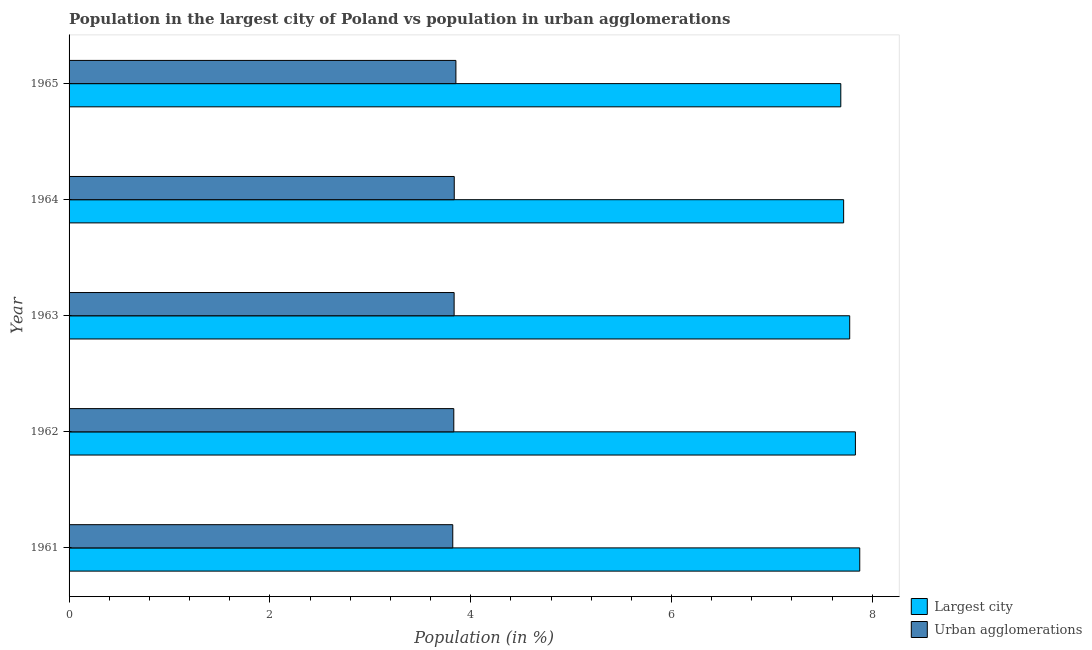How many groups of bars are there?
Provide a succinct answer. 5. How many bars are there on the 2nd tick from the top?
Provide a succinct answer. 2. How many bars are there on the 3rd tick from the bottom?
Your response must be concise. 2. What is the label of the 5th group of bars from the top?
Ensure brevity in your answer.  1961. In how many cases, is the number of bars for a given year not equal to the number of legend labels?
Your response must be concise. 0. What is the population in urban agglomerations in 1961?
Give a very brief answer. 3.82. Across all years, what is the maximum population in the largest city?
Offer a terse response. 7.88. Across all years, what is the minimum population in urban agglomerations?
Offer a terse response. 3.82. In which year was the population in the largest city minimum?
Provide a short and direct response. 1965. What is the total population in the largest city in the graph?
Your response must be concise. 38.88. What is the difference between the population in urban agglomerations in 1963 and that in 1964?
Ensure brevity in your answer.  -0. What is the difference between the population in the largest city in 1963 and the population in urban agglomerations in 1965?
Offer a very short reply. 3.92. What is the average population in urban agglomerations per year?
Offer a very short reply. 3.84. In the year 1961, what is the difference between the population in urban agglomerations and population in the largest city?
Ensure brevity in your answer.  -4.05. What is the difference between the highest and the second highest population in urban agglomerations?
Your answer should be very brief. 0.02. What is the difference between the highest and the lowest population in urban agglomerations?
Keep it short and to the point. 0.03. In how many years, is the population in the largest city greater than the average population in the largest city taken over all years?
Provide a short and direct response. 2. What does the 2nd bar from the top in 1964 represents?
Give a very brief answer. Largest city. What does the 1st bar from the bottom in 1961 represents?
Provide a succinct answer. Largest city. Are all the bars in the graph horizontal?
Give a very brief answer. Yes. What is the difference between two consecutive major ticks on the X-axis?
Offer a very short reply. 2. Are the values on the major ticks of X-axis written in scientific E-notation?
Make the answer very short. No. Does the graph contain any zero values?
Your answer should be compact. No. Does the graph contain grids?
Offer a terse response. No. Where does the legend appear in the graph?
Your answer should be very brief. Bottom right. How many legend labels are there?
Your response must be concise. 2. How are the legend labels stacked?
Offer a terse response. Vertical. What is the title of the graph?
Keep it short and to the point. Population in the largest city of Poland vs population in urban agglomerations. What is the label or title of the X-axis?
Your answer should be very brief. Population (in %). What is the Population (in %) of Largest city in 1961?
Offer a terse response. 7.88. What is the Population (in %) of Urban agglomerations in 1961?
Offer a terse response. 3.82. What is the Population (in %) in Largest city in 1962?
Offer a very short reply. 7.83. What is the Population (in %) in Urban agglomerations in 1962?
Your response must be concise. 3.83. What is the Population (in %) of Largest city in 1963?
Give a very brief answer. 7.78. What is the Population (in %) of Urban agglomerations in 1963?
Keep it short and to the point. 3.84. What is the Population (in %) of Largest city in 1964?
Ensure brevity in your answer.  7.71. What is the Population (in %) in Urban agglomerations in 1964?
Ensure brevity in your answer.  3.84. What is the Population (in %) in Largest city in 1965?
Your answer should be compact. 7.69. What is the Population (in %) of Urban agglomerations in 1965?
Offer a very short reply. 3.85. Across all years, what is the maximum Population (in %) in Largest city?
Offer a terse response. 7.88. Across all years, what is the maximum Population (in %) in Urban agglomerations?
Provide a short and direct response. 3.85. Across all years, what is the minimum Population (in %) in Largest city?
Your response must be concise. 7.69. Across all years, what is the minimum Population (in %) in Urban agglomerations?
Provide a short and direct response. 3.82. What is the total Population (in %) of Largest city in the graph?
Your answer should be very brief. 38.88. What is the total Population (in %) in Urban agglomerations in the graph?
Offer a terse response. 19.18. What is the difference between the Population (in %) in Largest city in 1961 and that in 1962?
Your answer should be very brief. 0.04. What is the difference between the Population (in %) of Urban agglomerations in 1961 and that in 1962?
Make the answer very short. -0.01. What is the difference between the Population (in %) of Largest city in 1961 and that in 1963?
Give a very brief answer. 0.1. What is the difference between the Population (in %) in Urban agglomerations in 1961 and that in 1963?
Your answer should be compact. -0.01. What is the difference between the Population (in %) in Largest city in 1961 and that in 1964?
Offer a terse response. 0.16. What is the difference between the Population (in %) of Urban agglomerations in 1961 and that in 1964?
Offer a very short reply. -0.01. What is the difference between the Population (in %) of Largest city in 1961 and that in 1965?
Offer a very short reply. 0.19. What is the difference between the Population (in %) of Urban agglomerations in 1961 and that in 1965?
Your answer should be very brief. -0.03. What is the difference between the Population (in %) of Largest city in 1962 and that in 1963?
Give a very brief answer. 0.06. What is the difference between the Population (in %) in Urban agglomerations in 1962 and that in 1963?
Your answer should be very brief. -0. What is the difference between the Population (in %) of Largest city in 1962 and that in 1964?
Offer a terse response. 0.12. What is the difference between the Population (in %) of Urban agglomerations in 1962 and that in 1964?
Provide a succinct answer. -0. What is the difference between the Population (in %) of Largest city in 1962 and that in 1965?
Provide a short and direct response. 0.15. What is the difference between the Population (in %) of Urban agglomerations in 1962 and that in 1965?
Make the answer very short. -0.02. What is the difference between the Population (in %) of Largest city in 1963 and that in 1964?
Offer a very short reply. 0.06. What is the difference between the Population (in %) in Urban agglomerations in 1963 and that in 1964?
Offer a very short reply. -0. What is the difference between the Population (in %) in Largest city in 1963 and that in 1965?
Keep it short and to the point. 0.09. What is the difference between the Population (in %) of Urban agglomerations in 1963 and that in 1965?
Your answer should be compact. -0.02. What is the difference between the Population (in %) in Largest city in 1964 and that in 1965?
Give a very brief answer. 0.03. What is the difference between the Population (in %) of Urban agglomerations in 1964 and that in 1965?
Your answer should be compact. -0.02. What is the difference between the Population (in %) in Largest city in 1961 and the Population (in %) in Urban agglomerations in 1962?
Ensure brevity in your answer.  4.04. What is the difference between the Population (in %) in Largest city in 1961 and the Population (in %) in Urban agglomerations in 1963?
Give a very brief answer. 4.04. What is the difference between the Population (in %) of Largest city in 1961 and the Population (in %) of Urban agglomerations in 1964?
Provide a succinct answer. 4.04. What is the difference between the Population (in %) in Largest city in 1961 and the Population (in %) in Urban agglomerations in 1965?
Offer a terse response. 4.02. What is the difference between the Population (in %) in Largest city in 1962 and the Population (in %) in Urban agglomerations in 1963?
Make the answer very short. 4. What is the difference between the Population (in %) in Largest city in 1962 and the Population (in %) in Urban agglomerations in 1964?
Your answer should be compact. 4. What is the difference between the Population (in %) of Largest city in 1962 and the Population (in %) of Urban agglomerations in 1965?
Your answer should be compact. 3.98. What is the difference between the Population (in %) in Largest city in 1963 and the Population (in %) in Urban agglomerations in 1964?
Provide a short and direct response. 3.94. What is the difference between the Population (in %) in Largest city in 1963 and the Population (in %) in Urban agglomerations in 1965?
Offer a terse response. 3.92. What is the difference between the Population (in %) of Largest city in 1964 and the Population (in %) of Urban agglomerations in 1965?
Your answer should be very brief. 3.86. What is the average Population (in %) in Largest city per year?
Keep it short and to the point. 7.78. What is the average Population (in %) of Urban agglomerations per year?
Give a very brief answer. 3.84. In the year 1961, what is the difference between the Population (in %) in Largest city and Population (in %) in Urban agglomerations?
Give a very brief answer. 4.05. In the year 1962, what is the difference between the Population (in %) in Largest city and Population (in %) in Urban agglomerations?
Offer a terse response. 4. In the year 1963, what is the difference between the Population (in %) of Largest city and Population (in %) of Urban agglomerations?
Your response must be concise. 3.94. In the year 1964, what is the difference between the Population (in %) in Largest city and Population (in %) in Urban agglomerations?
Provide a short and direct response. 3.88. In the year 1965, what is the difference between the Population (in %) in Largest city and Population (in %) in Urban agglomerations?
Ensure brevity in your answer.  3.83. What is the ratio of the Population (in %) of Largest city in 1961 to that in 1962?
Offer a very short reply. 1.01. What is the ratio of the Population (in %) in Largest city in 1961 to that in 1963?
Provide a succinct answer. 1.01. What is the ratio of the Population (in %) of Urban agglomerations in 1961 to that in 1963?
Your response must be concise. 1. What is the ratio of the Population (in %) in Largest city in 1961 to that in 1964?
Give a very brief answer. 1.02. What is the ratio of the Population (in %) of Largest city in 1961 to that in 1965?
Ensure brevity in your answer.  1.02. What is the ratio of the Population (in %) in Urban agglomerations in 1961 to that in 1965?
Your answer should be compact. 0.99. What is the ratio of the Population (in %) of Largest city in 1962 to that in 1963?
Keep it short and to the point. 1.01. What is the ratio of the Population (in %) in Largest city in 1962 to that in 1964?
Provide a succinct answer. 1.02. What is the ratio of the Population (in %) in Largest city in 1962 to that in 1965?
Ensure brevity in your answer.  1.02. What is the ratio of the Population (in %) in Largest city in 1963 to that in 1964?
Provide a short and direct response. 1.01. What is the ratio of the Population (in %) in Urban agglomerations in 1963 to that in 1964?
Ensure brevity in your answer.  1. What is the ratio of the Population (in %) of Largest city in 1963 to that in 1965?
Provide a short and direct response. 1.01. What is the ratio of the Population (in %) in Urban agglomerations in 1963 to that in 1965?
Make the answer very short. 1. What is the ratio of the Population (in %) in Largest city in 1964 to that in 1965?
Provide a succinct answer. 1. What is the difference between the highest and the second highest Population (in %) of Largest city?
Your answer should be compact. 0.04. What is the difference between the highest and the second highest Population (in %) of Urban agglomerations?
Make the answer very short. 0.02. What is the difference between the highest and the lowest Population (in %) of Largest city?
Ensure brevity in your answer.  0.19. What is the difference between the highest and the lowest Population (in %) in Urban agglomerations?
Provide a short and direct response. 0.03. 